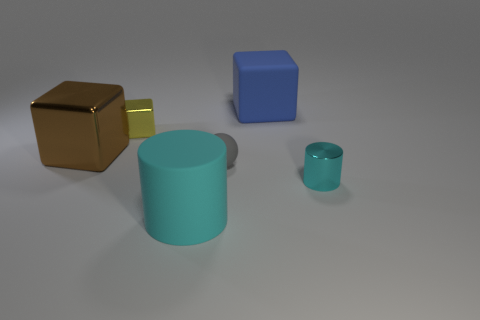What number of objects are either things that are behind the big brown metal thing or cyan objects that are to the left of the small cyan metallic thing? In the image, there is one object that fits the criteria of being behind the big brown metal box - it's the small yellow metallic cube. Additionally, to the left of the small cyan metallic cylinder, there are no cyan objects. So, in total, there is only one object that meets the specified conditions. 